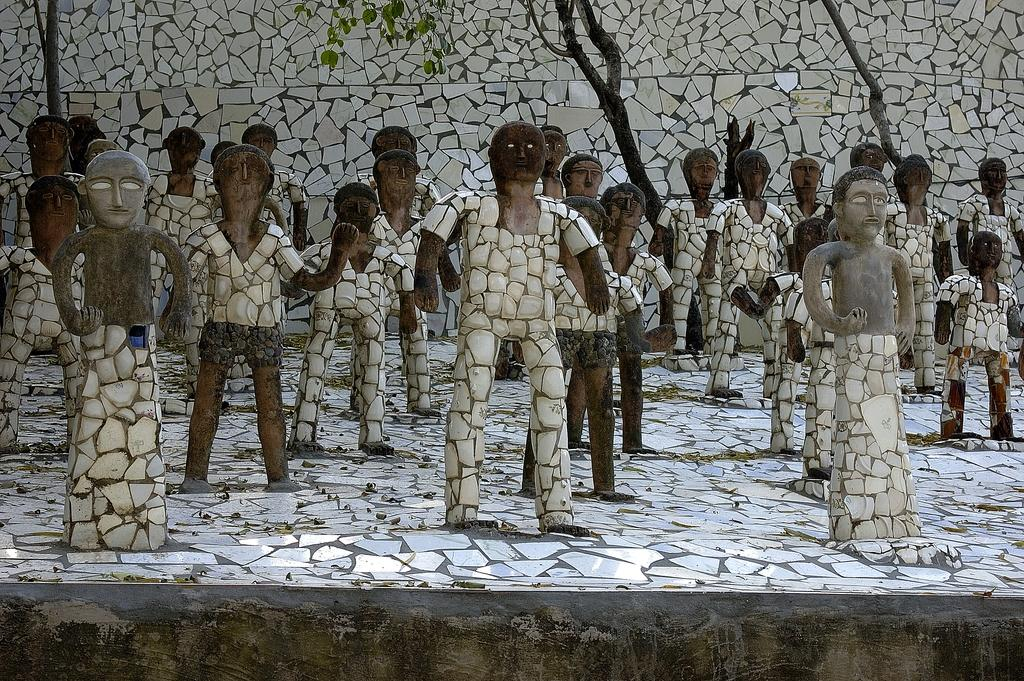Who or what can be seen in the image? There are people depicted in the image. What can be seen on the ground in the image? There is a path visible in the image. What type of vegetation is present in the image? Dried leaves and trees are present in the image. What is visible in the background of the image? There is a wall in the background of the image. How many kittens are playing with the fowl in the image? There are no kittens or fowl present in the image. What word is used to describe the action of stopping the people in the image? The image does not depict anyone stopping the people; there is no need for a word to describe such an action. 